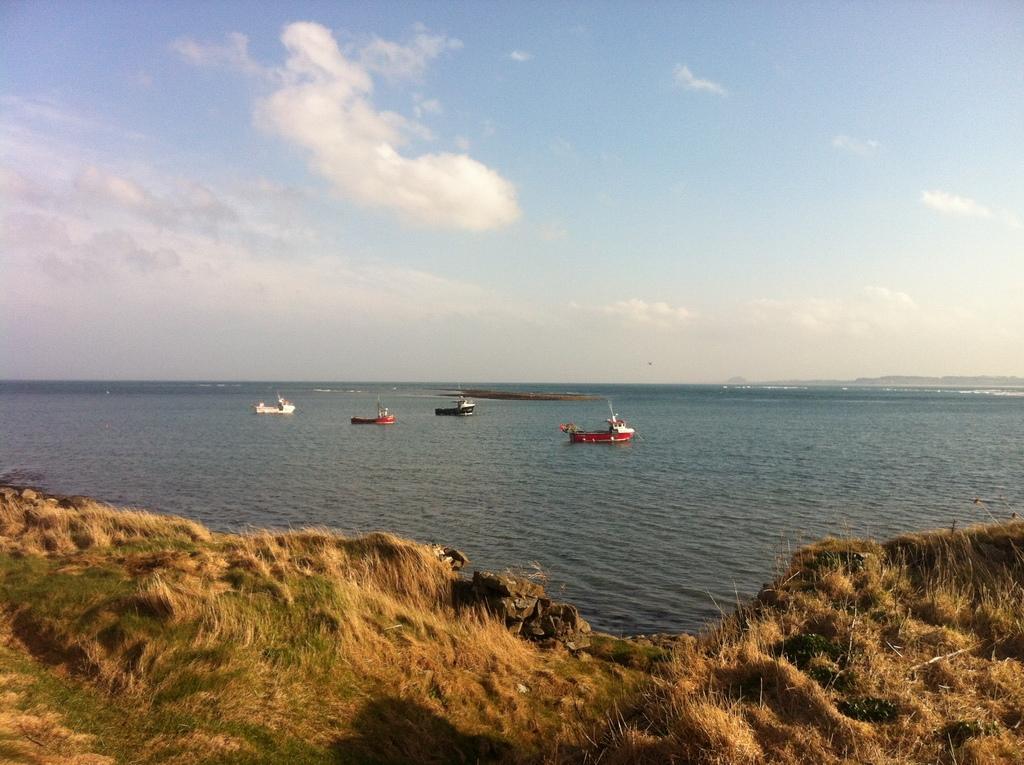Please provide a concise description of this image. In this picture we can observe some grass on the ground. In the background we can observe an ocean. There are some boats on the water. We can observe a sky with some clouds. 